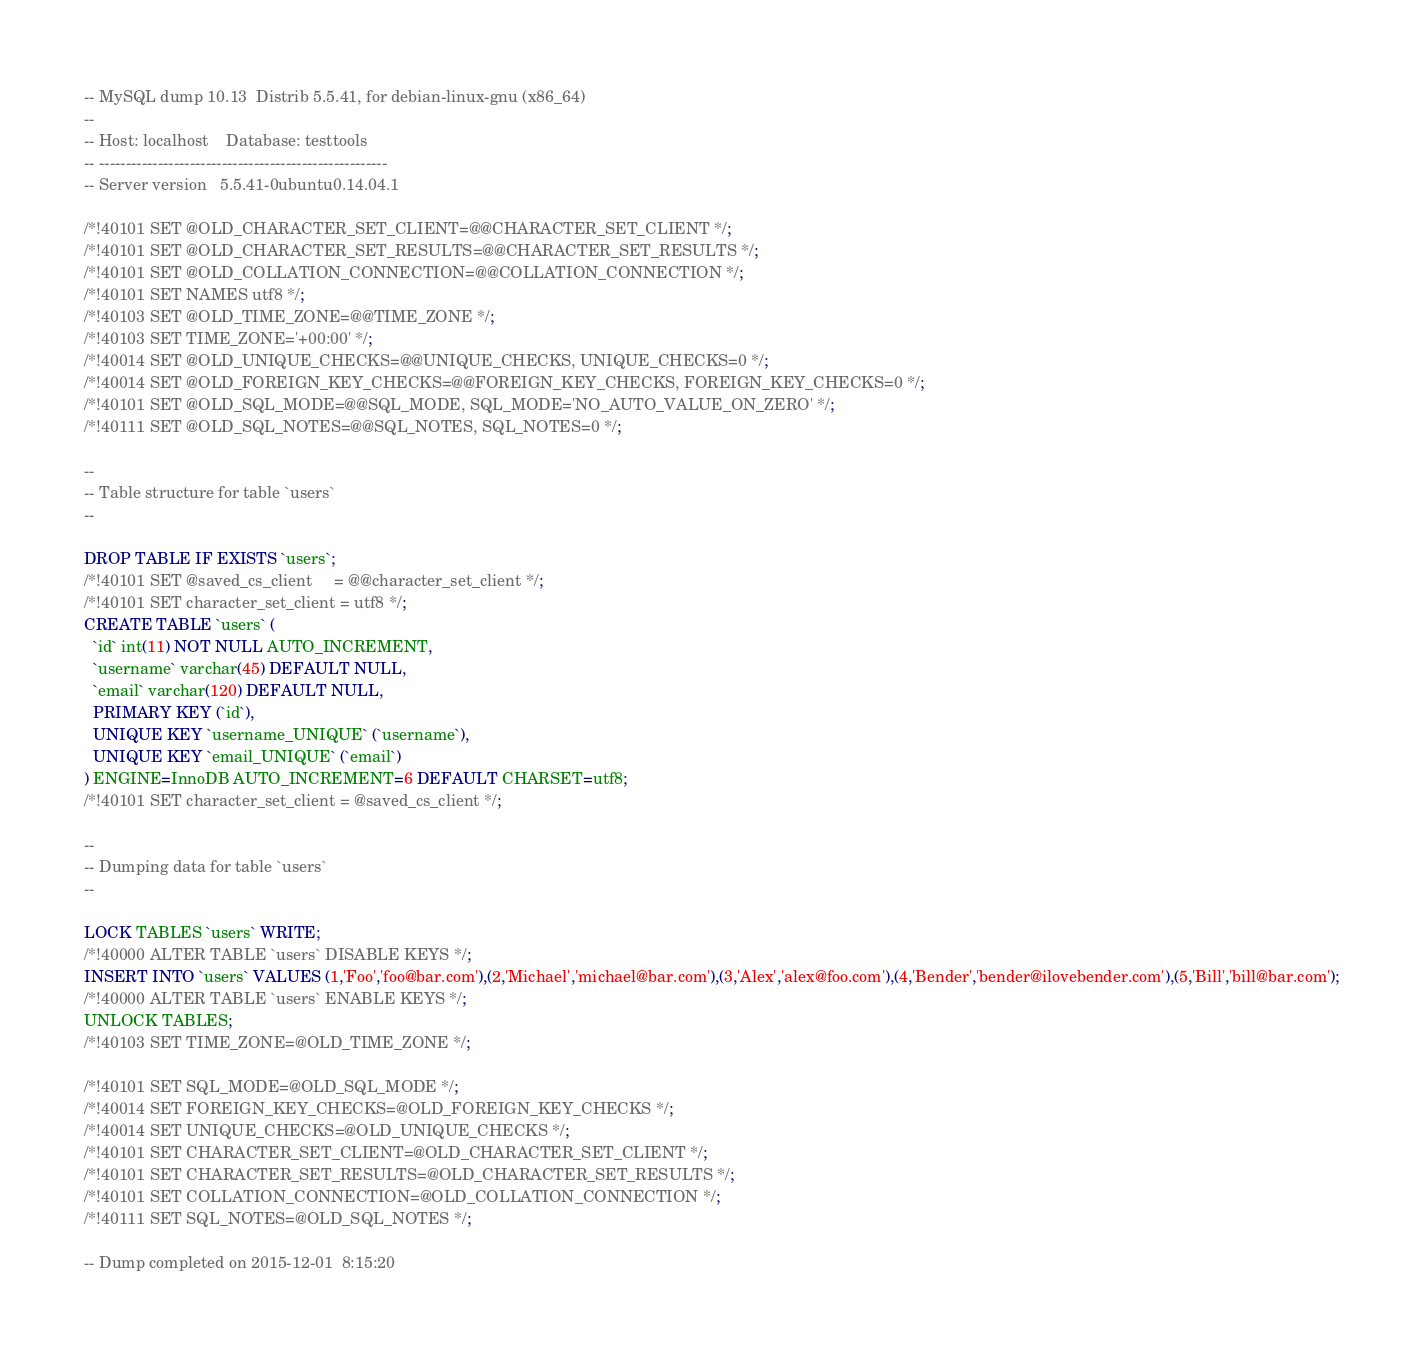<code> <loc_0><loc_0><loc_500><loc_500><_SQL_>-- MySQL dump 10.13  Distrib 5.5.41, for debian-linux-gnu (x86_64)
--
-- Host: localhost    Database: testtools
-- ------------------------------------------------------
-- Server version	5.5.41-0ubuntu0.14.04.1

/*!40101 SET @OLD_CHARACTER_SET_CLIENT=@@CHARACTER_SET_CLIENT */;
/*!40101 SET @OLD_CHARACTER_SET_RESULTS=@@CHARACTER_SET_RESULTS */;
/*!40101 SET @OLD_COLLATION_CONNECTION=@@COLLATION_CONNECTION */;
/*!40101 SET NAMES utf8 */;
/*!40103 SET @OLD_TIME_ZONE=@@TIME_ZONE */;
/*!40103 SET TIME_ZONE='+00:00' */;
/*!40014 SET @OLD_UNIQUE_CHECKS=@@UNIQUE_CHECKS, UNIQUE_CHECKS=0 */;
/*!40014 SET @OLD_FOREIGN_KEY_CHECKS=@@FOREIGN_KEY_CHECKS, FOREIGN_KEY_CHECKS=0 */;
/*!40101 SET @OLD_SQL_MODE=@@SQL_MODE, SQL_MODE='NO_AUTO_VALUE_ON_ZERO' */;
/*!40111 SET @OLD_SQL_NOTES=@@SQL_NOTES, SQL_NOTES=0 */;

--
-- Table structure for table `users`
--

DROP TABLE IF EXISTS `users`;
/*!40101 SET @saved_cs_client     = @@character_set_client */;
/*!40101 SET character_set_client = utf8 */;
CREATE TABLE `users` (
  `id` int(11) NOT NULL AUTO_INCREMENT,
  `username` varchar(45) DEFAULT NULL,
  `email` varchar(120) DEFAULT NULL,
  PRIMARY KEY (`id`),
  UNIQUE KEY `username_UNIQUE` (`username`),
  UNIQUE KEY `email_UNIQUE` (`email`)
) ENGINE=InnoDB AUTO_INCREMENT=6 DEFAULT CHARSET=utf8;
/*!40101 SET character_set_client = @saved_cs_client */;

--
-- Dumping data for table `users`
--

LOCK TABLES `users` WRITE;
/*!40000 ALTER TABLE `users` DISABLE KEYS */;
INSERT INTO `users` VALUES (1,'Foo','foo@bar.com'),(2,'Michael','michael@bar.com'),(3,'Alex','alex@foo.com'),(4,'Bender','bender@ilovebender.com'),(5,'Bill','bill@bar.com');
/*!40000 ALTER TABLE `users` ENABLE KEYS */;
UNLOCK TABLES;
/*!40103 SET TIME_ZONE=@OLD_TIME_ZONE */;

/*!40101 SET SQL_MODE=@OLD_SQL_MODE */;
/*!40014 SET FOREIGN_KEY_CHECKS=@OLD_FOREIGN_KEY_CHECKS */;
/*!40014 SET UNIQUE_CHECKS=@OLD_UNIQUE_CHECKS */;
/*!40101 SET CHARACTER_SET_CLIENT=@OLD_CHARACTER_SET_CLIENT */;
/*!40101 SET CHARACTER_SET_RESULTS=@OLD_CHARACTER_SET_RESULTS */;
/*!40101 SET COLLATION_CONNECTION=@OLD_COLLATION_CONNECTION */;
/*!40111 SET SQL_NOTES=@OLD_SQL_NOTES */;

-- Dump completed on 2015-12-01  8:15:20
</code> 